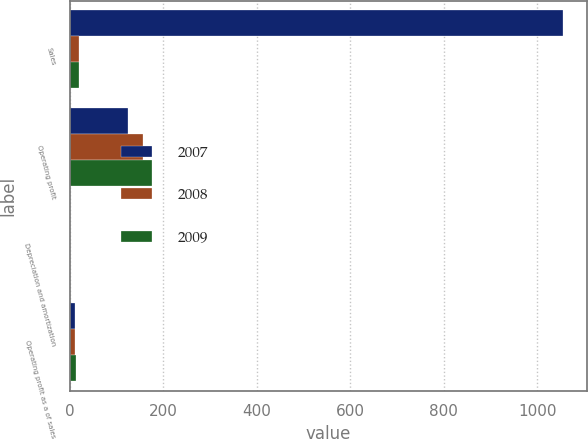<chart> <loc_0><loc_0><loc_500><loc_500><stacked_bar_chart><ecel><fcel>Sales<fcel>Operating profit<fcel>Depreciation and amortization<fcel>Operating profit as a of sales<nl><fcel>2007<fcel>1054.3<fcel>124.8<fcel>2<fcel>11.8<nl><fcel>2008<fcel>20.8<fcel>157.7<fcel>1.6<fcel>12.2<nl><fcel>2009<fcel>20.8<fcel>175.6<fcel>1.6<fcel>13.1<nl></chart> 